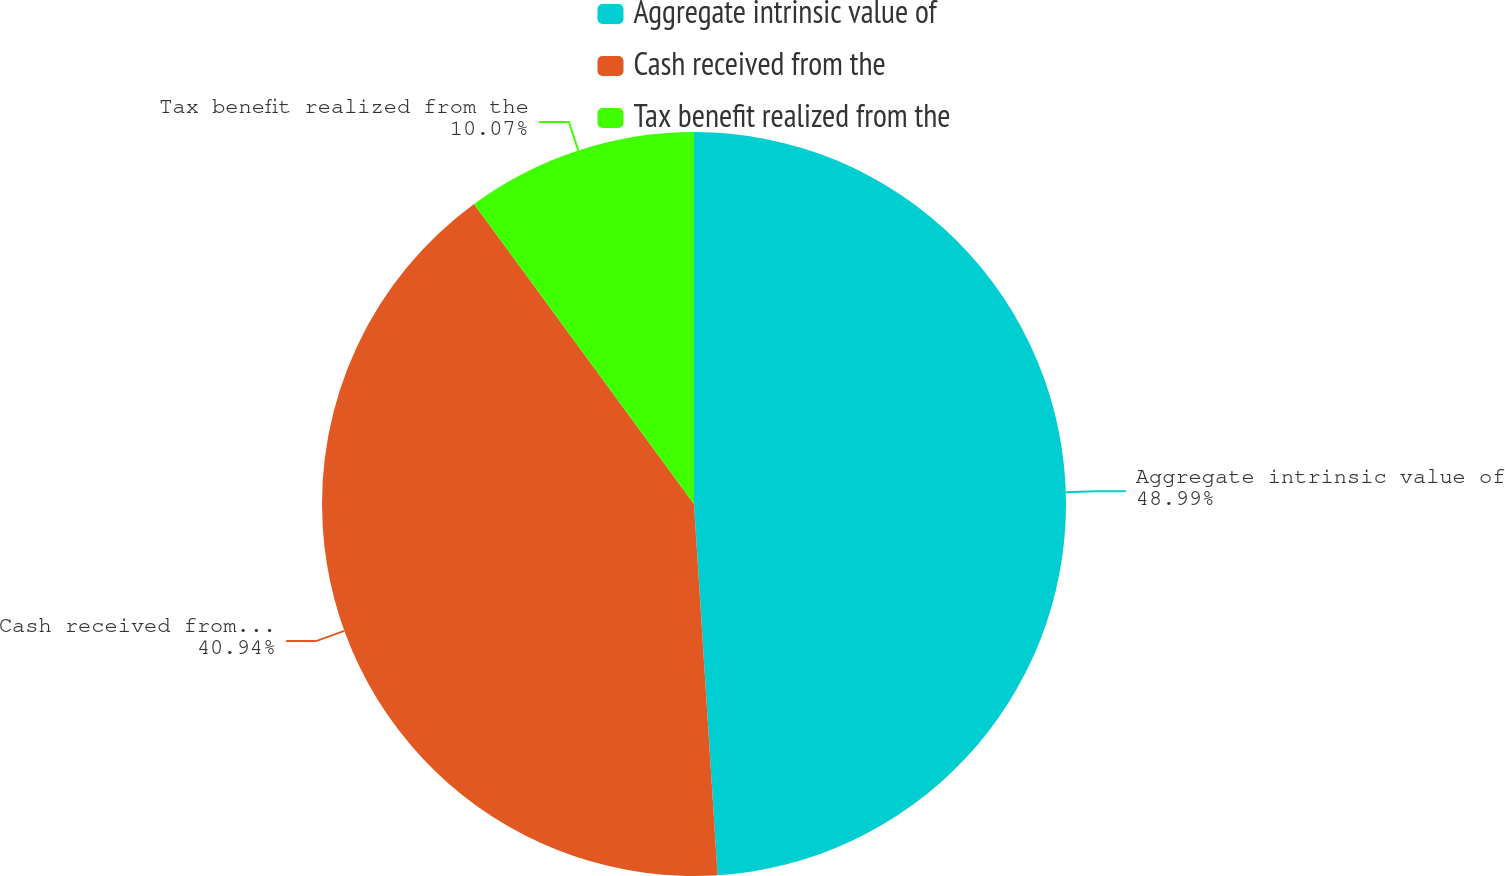Convert chart. <chart><loc_0><loc_0><loc_500><loc_500><pie_chart><fcel>Aggregate intrinsic value of<fcel>Cash received from the<fcel>Tax benefit realized from the<nl><fcel>48.99%<fcel>40.94%<fcel>10.07%<nl></chart> 